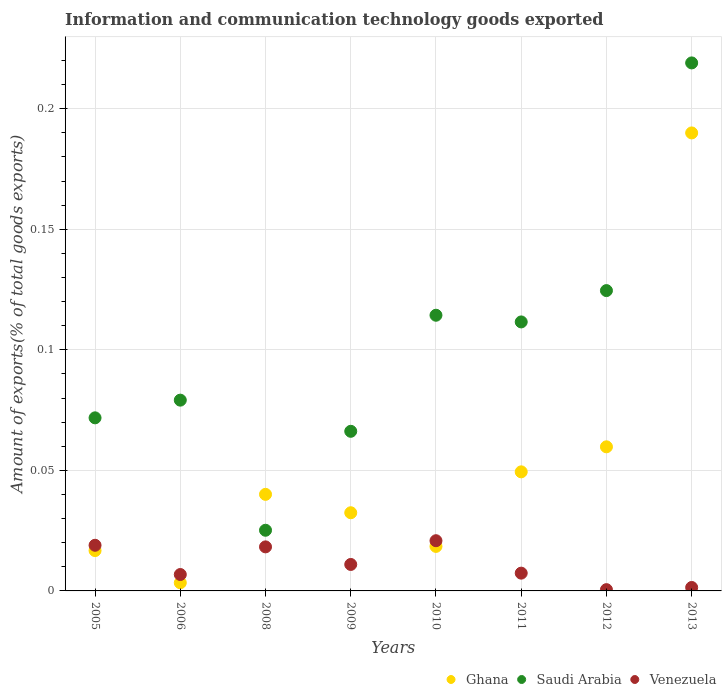Is the number of dotlines equal to the number of legend labels?
Offer a terse response. Yes. What is the amount of goods exported in Venezuela in 2013?
Your answer should be compact. 0. Across all years, what is the maximum amount of goods exported in Venezuela?
Provide a succinct answer. 0.02. Across all years, what is the minimum amount of goods exported in Ghana?
Offer a terse response. 0. In which year was the amount of goods exported in Venezuela maximum?
Your response must be concise. 2010. In which year was the amount of goods exported in Saudi Arabia minimum?
Provide a succinct answer. 2008. What is the total amount of goods exported in Venezuela in the graph?
Offer a very short reply. 0.09. What is the difference between the amount of goods exported in Ghana in 2009 and that in 2013?
Provide a succinct answer. -0.16. What is the difference between the amount of goods exported in Venezuela in 2011 and the amount of goods exported in Saudi Arabia in 2013?
Your answer should be compact. -0.21. What is the average amount of goods exported in Venezuela per year?
Your answer should be compact. 0.01. In the year 2008, what is the difference between the amount of goods exported in Ghana and amount of goods exported in Venezuela?
Provide a succinct answer. 0.02. In how many years, is the amount of goods exported in Venezuela greater than 0.19000000000000003 %?
Provide a succinct answer. 0. What is the ratio of the amount of goods exported in Ghana in 2008 to that in 2009?
Your answer should be very brief. 1.24. Is the amount of goods exported in Ghana in 2005 less than that in 2009?
Offer a terse response. Yes. Is the difference between the amount of goods exported in Ghana in 2005 and 2011 greater than the difference between the amount of goods exported in Venezuela in 2005 and 2011?
Keep it short and to the point. No. What is the difference between the highest and the second highest amount of goods exported in Venezuela?
Your response must be concise. 0. What is the difference between the highest and the lowest amount of goods exported in Saudi Arabia?
Your response must be concise. 0.19. Is the sum of the amount of goods exported in Saudi Arabia in 2005 and 2011 greater than the maximum amount of goods exported in Ghana across all years?
Give a very brief answer. No. Is it the case that in every year, the sum of the amount of goods exported in Venezuela and amount of goods exported in Saudi Arabia  is greater than the amount of goods exported in Ghana?
Your answer should be compact. Yes. Does the amount of goods exported in Ghana monotonically increase over the years?
Your response must be concise. No. Is the amount of goods exported in Ghana strictly greater than the amount of goods exported in Venezuela over the years?
Keep it short and to the point. No. Is the amount of goods exported in Saudi Arabia strictly less than the amount of goods exported in Ghana over the years?
Provide a short and direct response. No. How many dotlines are there?
Provide a succinct answer. 3. How many years are there in the graph?
Offer a very short reply. 8. What is the difference between two consecutive major ticks on the Y-axis?
Your answer should be compact. 0.05. Does the graph contain any zero values?
Your response must be concise. No. Does the graph contain grids?
Ensure brevity in your answer.  Yes. Where does the legend appear in the graph?
Keep it short and to the point. Bottom right. What is the title of the graph?
Offer a very short reply. Information and communication technology goods exported. Does "Micronesia" appear as one of the legend labels in the graph?
Offer a very short reply. No. What is the label or title of the Y-axis?
Your response must be concise. Amount of exports(% of total goods exports). What is the Amount of exports(% of total goods exports) in Ghana in 2005?
Provide a succinct answer. 0.02. What is the Amount of exports(% of total goods exports) in Saudi Arabia in 2005?
Your answer should be very brief. 0.07. What is the Amount of exports(% of total goods exports) of Venezuela in 2005?
Keep it short and to the point. 0.02. What is the Amount of exports(% of total goods exports) in Ghana in 2006?
Provide a succinct answer. 0. What is the Amount of exports(% of total goods exports) in Saudi Arabia in 2006?
Offer a terse response. 0.08. What is the Amount of exports(% of total goods exports) in Venezuela in 2006?
Offer a terse response. 0.01. What is the Amount of exports(% of total goods exports) in Ghana in 2008?
Make the answer very short. 0.04. What is the Amount of exports(% of total goods exports) of Saudi Arabia in 2008?
Your answer should be compact. 0.03. What is the Amount of exports(% of total goods exports) in Venezuela in 2008?
Offer a very short reply. 0.02. What is the Amount of exports(% of total goods exports) in Ghana in 2009?
Ensure brevity in your answer.  0.03. What is the Amount of exports(% of total goods exports) in Saudi Arabia in 2009?
Provide a succinct answer. 0.07. What is the Amount of exports(% of total goods exports) in Venezuela in 2009?
Your response must be concise. 0.01. What is the Amount of exports(% of total goods exports) of Ghana in 2010?
Your response must be concise. 0.02. What is the Amount of exports(% of total goods exports) of Saudi Arabia in 2010?
Ensure brevity in your answer.  0.11. What is the Amount of exports(% of total goods exports) of Venezuela in 2010?
Offer a very short reply. 0.02. What is the Amount of exports(% of total goods exports) in Ghana in 2011?
Give a very brief answer. 0.05. What is the Amount of exports(% of total goods exports) in Saudi Arabia in 2011?
Your answer should be compact. 0.11. What is the Amount of exports(% of total goods exports) of Venezuela in 2011?
Ensure brevity in your answer.  0.01. What is the Amount of exports(% of total goods exports) in Ghana in 2012?
Your response must be concise. 0.06. What is the Amount of exports(% of total goods exports) of Saudi Arabia in 2012?
Ensure brevity in your answer.  0.12. What is the Amount of exports(% of total goods exports) in Venezuela in 2012?
Keep it short and to the point. 0. What is the Amount of exports(% of total goods exports) of Ghana in 2013?
Your answer should be compact. 0.19. What is the Amount of exports(% of total goods exports) of Saudi Arabia in 2013?
Make the answer very short. 0.22. What is the Amount of exports(% of total goods exports) in Venezuela in 2013?
Offer a very short reply. 0. Across all years, what is the maximum Amount of exports(% of total goods exports) of Ghana?
Offer a terse response. 0.19. Across all years, what is the maximum Amount of exports(% of total goods exports) of Saudi Arabia?
Your response must be concise. 0.22. Across all years, what is the maximum Amount of exports(% of total goods exports) of Venezuela?
Your answer should be compact. 0.02. Across all years, what is the minimum Amount of exports(% of total goods exports) of Ghana?
Your answer should be compact. 0. Across all years, what is the minimum Amount of exports(% of total goods exports) of Saudi Arabia?
Your response must be concise. 0.03. Across all years, what is the minimum Amount of exports(% of total goods exports) of Venezuela?
Your answer should be compact. 0. What is the total Amount of exports(% of total goods exports) in Ghana in the graph?
Offer a terse response. 0.41. What is the total Amount of exports(% of total goods exports) of Saudi Arabia in the graph?
Provide a succinct answer. 0.81. What is the total Amount of exports(% of total goods exports) of Venezuela in the graph?
Offer a terse response. 0.09. What is the difference between the Amount of exports(% of total goods exports) of Ghana in 2005 and that in 2006?
Offer a terse response. 0.01. What is the difference between the Amount of exports(% of total goods exports) of Saudi Arabia in 2005 and that in 2006?
Give a very brief answer. -0.01. What is the difference between the Amount of exports(% of total goods exports) in Venezuela in 2005 and that in 2006?
Offer a terse response. 0.01. What is the difference between the Amount of exports(% of total goods exports) of Ghana in 2005 and that in 2008?
Provide a short and direct response. -0.02. What is the difference between the Amount of exports(% of total goods exports) of Saudi Arabia in 2005 and that in 2008?
Provide a short and direct response. 0.05. What is the difference between the Amount of exports(% of total goods exports) in Venezuela in 2005 and that in 2008?
Your answer should be very brief. 0. What is the difference between the Amount of exports(% of total goods exports) of Ghana in 2005 and that in 2009?
Offer a very short reply. -0.02. What is the difference between the Amount of exports(% of total goods exports) of Saudi Arabia in 2005 and that in 2009?
Keep it short and to the point. 0.01. What is the difference between the Amount of exports(% of total goods exports) of Venezuela in 2005 and that in 2009?
Keep it short and to the point. 0.01. What is the difference between the Amount of exports(% of total goods exports) of Ghana in 2005 and that in 2010?
Offer a very short reply. -0. What is the difference between the Amount of exports(% of total goods exports) of Saudi Arabia in 2005 and that in 2010?
Your answer should be compact. -0.04. What is the difference between the Amount of exports(% of total goods exports) of Venezuela in 2005 and that in 2010?
Offer a terse response. -0. What is the difference between the Amount of exports(% of total goods exports) of Ghana in 2005 and that in 2011?
Keep it short and to the point. -0.03. What is the difference between the Amount of exports(% of total goods exports) in Saudi Arabia in 2005 and that in 2011?
Provide a short and direct response. -0.04. What is the difference between the Amount of exports(% of total goods exports) in Venezuela in 2005 and that in 2011?
Your response must be concise. 0.01. What is the difference between the Amount of exports(% of total goods exports) in Ghana in 2005 and that in 2012?
Offer a very short reply. -0.04. What is the difference between the Amount of exports(% of total goods exports) in Saudi Arabia in 2005 and that in 2012?
Offer a terse response. -0.05. What is the difference between the Amount of exports(% of total goods exports) in Venezuela in 2005 and that in 2012?
Offer a very short reply. 0.02. What is the difference between the Amount of exports(% of total goods exports) in Ghana in 2005 and that in 2013?
Give a very brief answer. -0.17. What is the difference between the Amount of exports(% of total goods exports) of Saudi Arabia in 2005 and that in 2013?
Provide a short and direct response. -0.15. What is the difference between the Amount of exports(% of total goods exports) of Venezuela in 2005 and that in 2013?
Keep it short and to the point. 0.02. What is the difference between the Amount of exports(% of total goods exports) of Ghana in 2006 and that in 2008?
Your response must be concise. -0.04. What is the difference between the Amount of exports(% of total goods exports) of Saudi Arabia in 2006 and that in 2008?
Ensure brevity in your answer.  0.05. What is the difference between the Amount of exports(% of total goods exports) in Venezuela in 2006 and that in 2008?
Provide a succinct answer. -0.01. What is the difference between the Amount of exports(% of total goods exports) in Ghana in 2006 and that in 2009?
Provide a short and direct response. -0.03. What is the difference between the Amount of exports(% of total goods exports) in Saudi Arabia in 2006 and that in 2009?
Your response must be concise. 0.01. What is the difference between the Amount of exports(% of total goods exports) in Venezuela in 2006 and that in 2009?
Your response must be concise. -0. What is the difference between the Amount of exports(% of total goods exports) in Ghana in 2006 and that in 2010?
Offer a terse response. -0.02. What is the difference between the Amount of exports(% of total goods exports) of Saudi Arabia in 2006 and that in 2010?
Your answer should be compact. -0.04. What is the difference between the Amount of exports(% of total goods exports) of Venezuela in 2006 and that in 2010?
Ensure brevity in your answer.  -0.01. What is the difference between the Amount of exports(% of total goods exports) in Ghana in 2006 and that in 2011?
Give a very brief answer. -0.05. What is the difference between the Amount of exports(% of total goods exports) in Saudi Arabia in 2006 and that in 2011?
Your answer should be compact. -0.03. What is the difference between the Amount of exports(% of total goods exports) in Venezuela in 2006 and that in 2011?
Offer a very short reply. -0. What is the difference between the Amount of exports(% of total goods exports) in Ghana in 2006 and that in 2012?
Your response must be concise. -0.06. What is the difference between the Amount of exports(% of total goods exports) of Saudi Arabia in 2006 and that in 2012?
Provide a short and direct response. -0.05. What is the difference between the Amount of exports(% of total goods exports) of Venezuela in 2006 and that in 2012?
Offer a terse response. 0.01. What is the difference between the Amount of exports(% of total goods exports) in Ghana in 2006 and that in 2013?
Provide a succinct answer. -0.19. What is the difference between the Amount of exports(% of total goods exports) of Saudi Arabia in 2006 and that in 2013?
Your answer should be compact. -0.14. What is the difference between the Amount of exports(% of total goods exports) of Venezuela in 2006 and that in 2013?
Offer a terse response. 0.01. What is the difference between the Amount of exports(% of total goods exports) of Ghana in 2008 and that in 2009?
Ensure brevity in your answer.  0.01. What is the difference between the Amount of exports(% of total goods exports) of Saudi Arabia in 2008 and that in 2009?
Ensure brevity in your answer.  -0.04. What is the difference between the Amount of exports(% of total goods exports) in Venezuela in 2008 and that in 2009?
Offer a terse response. 0.01. What is the difference between the Amount of exports(% of total goods exports) of Ghana in 2008 and that in 2010?
Your response must be concise. 0.02. What is the difference between the Amount of exports(% of total goods exports) of Saudi Arabia in 2008 and that in 2010?
Provide a succinct answer. -0.09. What is the difference between the Amount of exports(% of total goods exports) of Venezuela in 2008 and that in 2010?
Provide a short and direct response. -0. What is the difference between the Amount of exports(% of total goods exports) in Ghana in 2008 and that in 2011?
Provide a succinct answer. -0.01. What is the difference between the Amount of exports(% of total goods exports) in Saudi Arabia in 2008 and that in 2011?
Your response must be concise. -0.09. What is the difference between the Amount of exports(% of total goods exports) of Venezuela in 2008 and that in 2011?
Make the answer very short. 0.01. What is the difference between the Amount of exports(% of total goods exports) of Ghana in 2008 and that in 2012?
Provide a succinct answer. -0.02. What is the difference between the Amount of exports(% of total goods exports) of Saudi Arabia in 2008 and that in 2012?
Give a very brief answer. -0.1. What is the difference between the Amount of exports(% of total goods exports) in Venezuela in 2008 and that in 2012?
Make the answer very short. 0.02. What is the difference between the Amount of exports(% of total goods exports) in Ghana in 2008 and that in 2013?
Keep it short and to the point. -0.15. What is the difference between the Amount of exports(% of total goods exports) of Saudi Arabia in 2008 and that in 2013?
Make the answer very short. -0.19. What is the difference between the Amount of exports(% of total goods exports) of Venezuela in 2008 and that in 2013?
Ensure brevity in your answer.  0.02. What is the difference between the Amount of exports(% of total goods exports) in Ghana in 2009 and that in 2010?
Provide a succinct answer. 0.01. What is the difference between the Amount of exports(% of total goods exports) in Saudi Arabia in 2009 and that in 2010?
Keep it short and to the point. -0.05. What is the difference between the Amount of exports(% of total goods exports) of Venezuela in 2009 and that in 2010?
Provide a short and direct response. -0.01. What is the difference between the Amount of exports(% of total goods exports) in Ghana in 2009 and that in 2011?
Ensure brevity in your answer.  -0.02. What is the difference between the Amount of exports(% of total goods exports) of Saudi Arabia in 2009 and that in 2011?
Provide a succinct answer. -0.05. What is the difference between the Amount of exports(% of total goods exports) of Venezuela in 2009 and that in 2011?
Your answer should be compact. 0. What is the difference between the Amount of exports(% of total goods exports) of Ghana in 2009 and that in 2012?
Your response must be concise. -0.03. What is the difference between the Amount of exports(% of total goods exports) in Saudi Arabia in 2009 and that in 2012?
Your answer should be very brief. -0.06. What is the difference between the Amount of exports(% of total goods exports) of Venezuela in 2009 and that in 2012?
Offer a terse response. 0.01. What is the difference between the Amount of exports(% of total goods exports) in Ghana in 2009 and that in 2013?
Your response must be concise. -0.16. What is the difference between the Amount of exports(% of total goods exports) of Saudi Arabia in 2009 and that in 2013?
Make the answer very short. -0.15. What is the difference between the Amount of exports(% of total goods exports) in Venezuela in 2009 and that in 2013?
Give a very brief answer. 0.01. What is the difference between the Amount of exports(% of total goods exports) of Ghana in 2010 and that in 2011?
Your response must be concise. -0.03. What is the difference between the Amount of exports(% of total goods exports) of Saudi Arabia in 2010 and that in 2011?
Give a very brief answer. 0. What is the difference between the Amount of exports(% of total goods exports) in Venezuela in 2010 and that in 2011?
Your answer should be very brief. 0.01. What is the difference between the Amount of exports(% of total goods exports) in Ghana in 2010 and that in 2012?
Give a very brief answer. -0.04. What is the difference between the Amount of exports(% of total goods exports) of Saudi Arabia in 2010 and that in 2012?
Your answer should be compact. -0.01. What is the difference between the Amount of exports(% of total goods exports) in Venezuela in 2010 and that in 2012?
Your answer should be compact. 0.02. What is the difference between the Amount of exports(% of total goods exports) in Ghana in 2010 and that in 2013?
Your response must be concise. -0.17. What is the difference between the Amount of exports(% of total goods exports) in Saudi Arabia in 2010 and that in 2013?
Keep it short and to the point. -0.1. What is the difference between the Amount of exports(% of total goods exports) in Venezuela in 2010 and that in 2013?
Give a very brief answer. 0.02. What is the difference between the Amount of exports(% of total goods exports) in Ghana in 2011 and that in 2012?
Provide a short and direct response. -0.01. What is the difference between the Amount of exports(% of total goods exports) of Saudi Arabia in 2011 and that in 2012?
Make the answer very short. -0.01. What is the difference between the Amount of exports(% of total goods exports) in Venezuela in 2011 and that in 2012?
Give a very brief answer. 0.01. What is the difference between the Amount of exports(% of total goods exports) of Ghana in 2011 and that in 2013?
Your answer should be very brief. -0.14. What is the difference between the Amount of exports(% of total goods exports) in Saudi Arabia in 2011 and that in 2013?
Provide a succinct answer. -0.11. What is the difference between the Amount of exports(% of total goods exports) of Venezuela in 2011 and that in 2013?
Provide a succinct answer. 0.01. What is the difference between the Amount of exports(% of total goods exports) of Ghana in 2012 and that in 2013?
Offer a terse response. -0.13. What is the difference between the Amount of exports(% of total goods exports) in Saudi Arabia in 2012 and that in 2013?
Provide a short and direct response. -0.09. What is the difference between the Amount of exports(% of total goods exports) in Venezuela in 2012 and that in 2013?
Give a very brief answer. -0. What is the difference between the Amount of exports(% of total goods exports) in Ghana in 2005 and the Amount of exports(% of total goods exports) in Saudi Arabia in 2006?
Provide a succinct answer. -0.06. What is the difference between the Amount of exports(% of total goods exports) of Ghana in 2005 and the Amount of exports(% of total goods exports) of Venezuela in 2006?
Offer a terse response. 0.01. What is the difference between the Amount of exports(% of total goods exports) of Saudi Arabia in 2005 and the Amount of exports(% of total goods exports) of Venezuela in 2006?
Ensure brevity in your answer.  0.07. What is the difference between the Amount of exports(% of total goods exports) of Ghana in 2005 and the Amount of exports(% of total goods exports) of Saudi Arabia in 2008?
Provide a succinct answer. -0.01. What is the difference between the Amount of exports(% of total goods exports) in Ghana in 2005 and the Amount of exports(% of total goods exports) in Venezuela in 2008?
Provide a short and direct response. -0. What is the difference between the Amount of exports(% of total goods exports) of Saudi Arabia in 2005 and the Amount of exports(% of total goods exports) of Venezuela in 2008?
Keep it short and to the point. 0.05. What is the difference between the Amount of exports(% of total goods exports) of Ghana in 2005 and the Amount of exports(% of total goods exports) of Saudi Arabia in 2009?
Provide a succinct answer. -0.05. What is the difference between the Amount of exports(% of total goods exports) in Ghana in 2005 and the Amount of exports(% of total goods exports) in Venezuela in 2009?
Your response must be concise. 0.01. What is the difference between the Amount of exports(% of total goods exports) in Saudi Arabia in 2005 and the Amount of exports(% of total goods exports) in Venezuela in 2009?
Offer a very short reply. 0.06. What is the difference between the Amount of exports(% of total goods exports) in Ghana in 2005 and the Amount of exports(% of total goods exports) in Saudi Arabia in 2010?
Make the answer very short. -0.1. What is the difference between the Amount of exports(% of total goods exports) in Ghana in 2005 and the Amount of exports(% of total goods exports) in Venezuela in 2010?
Your answer should be very brief. -0. What is the difference between the Amount of exports(% of total goods exports) in Saudi Arabia in 2005 and the Amount of exports(% of total goods exports) in Venezuela in 2010?
Provide a short and direct response. 0.05. What is the difference between the Amount of exports(% of total goods exports) of Ghana in 2005 and the Amount of exports(% of total goods exports) of Saudi Arabia in 2011?
Provide a succinct answer. -0.09. What is the difference between the Amount of exports(% of total goods exports) in Ghana in 2005 and the Amount of exports(% of total goods exports) in Venezuela in 2011?
Offer a terse response. 0.01. What is the difference between the Amount of exports(% of total goods exports) of Saudi Arabia in 2005 and the Amount of exports(% of total goods exports) of Venezuela in 2011?
Provide a succinct answer. 0.06. What is the difference between the Amount of exports(% of total goods exports) in Ghana in 2005 and the Amount of exports(% of total goods exports) in Saudi Arabia in 2012?
Offer a terse response. -0.11. What is the difference between the Amount of exports(% of total goods exports) in Ghana in 2005 and the Amount of exports(% of total goods exports) in Venezuela in 2012?
Provide a short and direct response. 0.02. What is the difference between the Amount of exports(% of total goods exports) of Saudi Arabia in 2005 and the Amount of exports(% of total goods exports) of Venezuela in 2012?
Offer a very short reply. 0.07. What is the difference between the Amount of exports(% of total goods exports) of Ghana in 2005 and the Amount of exports(% of total goods exports) of Saudi Arabia in 2013?
Offer a very short reply. -0.2. What is the difference between the Amount of exports(% of total goods exports) of Ghana in 2005 and the Amount of exports(% of total goods exports) of Venezuela in 2013?
Give a very brief answer. 0.02. What is the difference between the Amount of exports(% of total goods exports) of Saudi Arabia in 2005 and the Amount of exports(% of total goods exports) of Venezuela in 2013?
Your answer should be very brief. 0.07. What is the difference between the Amount of exports(% of total goods exports) in Ghana in 2006 and the Amount of exports(% of total goods exports) in Saudi Arabia in 2008?
Make the answer very short. -0.02. What is the difference between the Amount of exports(% of total goods exports) in Ghana in 2006 and the Amount of exports(% of total goods exports) in Venezuela in 2008?
Provide a short and direct response. -0.01. What is the difference between the Amount of exports(% of total goods exports) in Saudi Arabia in 2006 and the Amount of exports(% of total goods exports) in Venezuela in 2008?
Your answer should be compact. 0.06. What is the difference between the Amount of exports(% of total goods exports) in Ghana in 2006 and the Amount of exports(% of total goods exports) in Saudi Arabia in 2009?
Give a very brief answer. -0.06. What is the difference between the Amount of exports(% of total goods exports) in Ghana in 2006 and the Amount of exports(% of total goods exports) in Venezuela in 2009?
Offer a terse response. -0.01. What is the difference between the Amount of exports(% of total goods exports) in Saudi Arabia in 2006 and the Amount of exports(% of total goods exports) in Venezuela in 2009?
Keep it short and to the point. 0.07. What is the difference between the Amount of exports(% of total goods exports) in Ghana in 2006 and the Amount of exports(% of total goods exports) in Saudi Arabia in 2010?
Your response must be concise. -0.11. What is the difference between the Amount of exports(% of total goods exports) in Ghana in 2006 and the Amount of exports(% of total goods exports) in Venezuela in 2010?
Offer a terse response. -0.02. What is the difference between the Amount of exports(% of total goods exports) of Saudi Arabia in 2006 and the Amount of exports(% of total goods exports) of Venezuela in 2010?
Your answer should be very brief. 0.06. What is the difference between the Amount of exports(% of total goods exports) of Ghana in 2006 and the Amount of exports(% of total goods exports) of Saudi Arabia in 2011?
Give a very brief answer. -0.11. What is the difference between the Amount of exports(% of total goods exports) of Ghana in 2006 and the Amount of exports(% of total goods exports) of Venezuela in 2011?
Provide a succinct answer. -0. What is the difference between the Amount of exports(% of total goods exports) of Saudi Arabia in 2006 and the Amount of exports(% of total goods exports) of Venezuela in 2011?
Provide a succinct answer. 0.07. What is the difference between the Amount of exports(% of total goods exports) of Ghana in 2006 and the Amount of exports(% of total goods exports) of Saudi Arabia in 2012?
Offer a terse response. -0.12. What is the difference between the Amount of exports(% of total goods exports) of Ghana in 2006 and the Amount of exports(% of total goods exports) of Venezuela in 2012?
Your answer should be very brief. 0. What is the difference between the Amount of exports(% of total goods exports) of Saudi Arabia in 2006 and the Amount of exports(% of total goods exports) of Venezuela in 2012?
Your answer should be very brief. 0.08. What is the difference between the Amount of exports(% of total goods exports) of Ghana in 2006 and the Amount of exports(% of total goods exports) of Saudi Arabia in 2013?
Offer a very short reply. -0.22. What is the difference between the Amount of exports(% of total goods exports) in Ghana in 2006 and the Amount of exports(% of total goods exports) in Venezuela in 2013?
Offer a very short reply. 0. What is the difference between the Amount of exports(% of total goods exports) in Saudi Arabia in 2006 and the Amount of exports(% of total goods exports) in Venezuela in 2013?
Offer a terse response. 0.08. What is the difference between the Amount of exports(% of total goods exports) of Ghana in 2008 and the Amount of exports(% of total goods exports) of Saudi Arabia in 2009?
Offer a terse response. -0.03. What is the difference between the Amount of exports(% of total goods exports) in Ghana in 2008 and the Amount of exports(% of total goods exports) in Venezuela in 2009?
Your answer should be compact. 0.03. What is the difference between the Amount of exports(% of total goods exports) of Saudi Arabia in 2008 and the Amount of exports(% of total goods exports) of Venezuela in 2009?
Give a very brief answer. 0.01. What is the difference between the Amount of exports(% of total goods exports) of Ghana in 2008 and the Amount of exports(% of total goods exports) of Saudi Arabia in 2010?
Ensure brevity in your answer.  -0.07. What is the difference between the Amount of exports(% of total goods exports) in Ghana in 2008 and the Amount of exports(% of total goods exports) in Venezuela in 2010?
Provide a short and direct response. 0.02. What is the difference between the Amount of exports(% of total goods exports) of Saudi Arabia in 2008 and the Amount of exports(% of total goods exports) of Venezuela in 2010?
Provide a succinct answer. 0. What is the difference between the Amount of exports(% of total goods exports) of Ghana in 2008 and the Amount of exports(% of total goods exports) of Saudi Arabia in 2011?
Offer a very short reply. -0.07. What is the difference between the Amount of exports(% of total goods exports) of Ghana in 2008 and the Amount of exports(% of total goods exports) of Venezuela in 2011?
Make the answer very short. 0.03. What is the difference between the Amount of exports(% of total goods exports) of Saudi Arabia in 2008 and the Amount of exports(% of total goods exports) of Venezuela in 2011?
Provide a succinct answer. 0.02. What is the difference between the Amount of exports(% of total goods exports) of Ghana in 2008 and the Amount of exports(% of total goods exports) of Saudi Arabia in 2012?
Make the answer very short. -0.08. What is the difference between the Amount of exports(% of total goods exports) of Ghana in 2008 and the Amount of exports(% of total goods exports) of Venezuela in 2012?
Offer a terse response. 0.04. What is the difference between the Amount of exports(% of total goods exports) of Saudi Arabia in 2008 and the Amount of exports(% of total goods exports) of Venezuela in 2012?
Provide a succinct answer. 0.02. What is the difference between the Amount of exports(% of total goods exports) of Ghana in 2008 and the Amount of exports(% of total goods exports) of Saudi Arabia in 2013?
Keep it short and to the point. -0.18. What is the difference between the Amount of exports(% of total goods exports) in Ghana in 2008 and the Amount of exports(% of total goods exports) in Venezuela in 2013?
Provide a succinct answer. 0.04. What is the difference between the Amount of exports(% of total goods exports) in Saudi Arabia in 2008 and the Amount of exports(% of total goods exports) in Venezuela in 2013?
Keep it short and to the point. 0.02. What is the difference between the Amount of exports(% of total goods exports) in Ghana in 2009 and the Amount of exports(% of total goods exports) in Saudi Arabia in 2010?
Provide a succinct answer. -0.08. What is the difference between the Amount of exports(% of total goods exports) of Ghana in 2009 and the Amount of exports(% of total goods exports) of Venezuela in 2010?
Your answer should be very brief. 0.01. What is the difference between the Amount of exports(% of total goods exports) in Saudi Arabia in 2009 and the Amount of exports(% of total goods exports) in Venezuela in 2010?
Offer a terse response. 0.05. What is the difference between the Amount of exports(% of total goods exports) in Ghana in 2009 and the Amount of exports(% of total goods exports) in Saudi Arabia in 2011?
Make the answer very short. -0.08. What is the difference between the Amount of exports(% of total goods exports) in Ghana in 2009 and the Amount of exports(% of total goods exports) in Venezuela in 2011?
Your answer should be compact. 0.03. What is the difference between the Amount of exports(% of total goods exports) of Saudi Arabia in 2009 and the Amount of exports(% of total goods exports) of Venezuela in 2011?
Provide a succinct answer. 0.06. What is the difference between the Amount of exports(% of total goods exports) in Ghana in 2009 and the Amount of exports(% of total goods exports) in Saudi Arabia in 2012?
Offer a very short reply. -0.09. What is the difference between the Amount of exports(% of total goods exports) in Ghana in 2009 and the Amount of exports(% of total goods exports) in Venezuela in 2012?
Ensure brevity in your answer.  0.03. What is the difference between the Amount of exports(% of total goods exports) in Saudi Arabia in 2009 and the Amount of exports(% of total goods exports) in Venezuela in 2012?
Your response must be concise. 0.07. What is the difference between the Amount of exports(% of total goods exports) of Ghana in 2009 and the Amount of exports(% of total goods exports) of Saudi Arabia in 2013?
Provide a short and direct response. -0.19. What is the difference between the Amount of exports(% of total goods exports) in Ghana in 2009 and the Amount of exports(% of total goods exports) in Venezuela in 2013?
Your answer should be very brief. 0.03. What is the difference between the Amount of exports(% of total goods exports) of Saudi Arabia in 2009 and the Amount of exports(% of total goods exports) of Venezuela in 2013?
Offer a terse response. 0.06. What is the difference between the Amount of exports(% of total goods exports) in Ghana in 2010 and the Amount of exports(% of total goods exports) in Saudi Arabia in 2011?
Make the answer very short. -0.09. What is the difference between the Amount of exports(% of total goods exports) of Ghana in 2010 and the Amount of exports(% of total goods exports) of Venezuela in 2011?
Offer a very short reply. 0.01. What is the difference between the Amount of exports(% of total goods exports) of Saudi Arabia in 2010 and the Amount of exports(% of total goods exports) of Venezuela in 2011?
Your answer should be compact. 0.11. What is the difference between the Amount of exports(% of total goods exports) in Ghana in 2010 and the Amount of exports(% of total goods exports) in Saudi Arabia in 2012?
Keep it short and to the point. -0.11. What is the difference between the Amount of exports(% of total goods exports) in Ghana in 2010 and the Amount of exports(% of total goods exports) in Venezuela in 2012?
Offer a very short reply. 0.02. What is the difference between the Amount of exports(% of total goods exports) of Saudi Arabia in 2010 and the Amount of exports(% of total goods exports) of Venezuela in 2012?
Offer a very short reply. 0.11. What is the difference between the Amount of exports(% of total goods exports) of Ghana in 2010 and the Amount of exports(% of total goods exports) of Saudi Arabia in 2013?
Your response must be concise. -0.2. What is the difference between the Amount of exports(% of total goods exports) of Ghana in 2010 and the Amount of exports(% of total goods exports) of Venezuela in 2013?
Make the answer very short. 0.02. What is the difference between the Amount of exports(% of total goods exports) of Saudi Arabia in 2010 and the Amount of exports(% of total goods exports) of Venezuela in 2013?
Ensure brevity in your answer.  0.11. What is the difference between the Amount of exports(% of total goods exports) of Ghana in 2011 and the Amount of exports(% of total goods exports) of Saudi Arabia in 2012?
Provide a short and direct response. -0.08. What is the difference between the Amount of exports(% of total goods exports) of Ghana in 2011 and the Amount of exports(% of total goods exports) of Venezuela in 2012?
Offer a terse response. 0.05. What is the difference between the Amount of exports(% of total goods exports) of Saudi Arabia in 2011 and the Amount of exports(% of total goods exports) of Venezuela in 2012?
Your answer should be compact. 0.11. What is the difference between the Amount of exports(% of total goods exports) of Ghana in 2011 and the Amount of exports(% of total goods exports) of Saudi Arabia in 2013?
Your response must be concise. -0.17. What is the difference between the Amount of exports(% of total goods exports) of Ghana in 2011 and the Amount of exports(% of total goods exports) of Venezuela in 2013?
Make the answer very short. 0.05. What is the difference between the Amount of exports(% of total goods exports) in Saudi Arabia in 2011 and the Amount of exports(% of total goods exports) in Venezuela in 2013?
Provide a succinct answer. 0.11. What is the difference between the Amount of exports(% of total goods exports) in Ghana in 2012 and the Amount of exports(% of total goods exports) in Saudi Arabia in 2013?
Your answer should be compact. -0.16. What is the difference between the Amount of exports(% of total goods exports) in Ghana in 2012 and the Amount of exports(% of total goods exports) in Venezuela in 2013?
Offer a terse response. 0.06. What is the difference between the Amount of exports(% of total goods exports) in Saudi Arabia in 2012 and the Amount of exports(% of total goods exports) in Venezuela in 2013?
Your response must be concise. 0.12. What is the average Amount of exports(% of total goods exports) of Ghana per year?
Make the answer very short. 0.05. What is the average Amount of exports(% of total goods exports) of Saudi Arabia per year?
Your answer should be compact. 0.1. What is the average Amount of exports(% of total goods exports) of Venezuela per year?
Your response must be concise. 0.01. In the year 2005, what is the difference between the Amount of exports(% of total goods exports) of Ghana and Amount of exports(% of total goods exports) of Saudi Arabia?
Offer a terse response. -0.06. In the year 2005, what is the difference between the Amount of exports(% of total goods exports) in Ghana and Amount of exports(% of total goods exports) in Venezuela?
Your answer should be very brief. -0. In the year 2005, what is the difference between the Amount of exports(% of total goods exports) of Saudi Arabia and Amount of exports(% of total goods exports) of Venezuela?
Your answer should be compact. 0.05. In the year 2006, what is the difference between the Amount of exports(% of total goods exports) in Ghana and Amount of exports(% of total goods exports) in Saudi Arabia?
Offer a very short reply. -0.08. In the year 2006, what is the difference between the Amount of exports(% of total goods exports) in Ghana and Amount of exports(% of total goods exports) in Venezuela?
Give a very brief answer. -0. In the year 2006, what is the difference between the Amount of exports(% of total goods exports) in Saudi Arabia and Amount of exports(% of total goods exports) in Venezuela?
Provide a succinct answer. 0.07. In the year 2008, what is the difference between the Amount of exports(% of total goods exports) in Ghana and Amount of exports(% of total goods exports) in Saudi Arabia?
Provide a short and direct response. 0.01. In the year 2008, what is the difference between the Amount of exports(% of total goods exports) in Ghana and Amount of exports(% of total goods exports) in Venezuela?
Offer a terse response. 0.02. In the year 2008, what is the difference between the Amount of exports(% of total goods exports) of Saudi Arabia and Amount of exports(% of total goods exports) of Venezuela?
Make the answer very short. 0.01. In the year 2009, what is the difference between the Amount of exports(% of total goods exports) of Ghana and Amount of exports(% of total goods exports) of Saudi Arabia?
Provide a succinct answer. -0.03. In the year 2009, what is the difference between the Amount of exports(% of total goods exports) of Ghana and Amount of exports(% of total goods exports) of Venezuela?
Offer a very short reply. 0.02. In the year 2009, what is the difference between the Amount of exports(% of total goods exports) of Saudi Arabia and Amount of exports(% of total goods exports) of Venezuela?
Give a very brief answer. 0.06. In the year 2010, what is the difference between the Amount of exports(% of total goods exports) of Ghana and Amount of exports(% of total goods exports) of Saudi Arabia?
Your answer should be compact. -0.1. In the year 2010, what is the difference between the Amount of exports(% of total goods exports) in Ghana and Amount of exports(% of total goods exports) in Venezuela?
Your answer should be very brief. -0. In the year 2010, what is the difference between the Amount of exports(% of total goods exports) of Saudi Arabia and Amount of exports(% of total goods exports) of Venezuela?
Offer a very short reply. 0.09. In the year 2011, what is the difference between the Amount of exports(% of total goods exports) in Ghana and Amount of exports(% of total goods exports) in Saudi Arabia?
Make the answer very short. -0.06. In the year 2011, what is the difference between the Amount of exports(% of total goods exports) of Ghana and Amount of exports(% of total goods exports) of Venezuela?
Provide a short and direct response. 0.04. In the year 2011, what is the difference between the Amount of exports(% of total goods exports) of Saudi Arabia and Amount of exports(% of total goods exports) of Venezuela?
Your answer should be very brief. 0.1. In the year 2012, what is the difference between the Amount of exports(% of total goods exports) of Ghana and Amount of exports(% of total goods exports) of Saudi Arabia?
Offer a terse response. -0.06. In the year 2012, what is the difference between the Amount of exports(% of total goods exports) of Ghana and Amount of exports(% of total goods exports) of Venezuela?
Provide a short and direct response. 0.06. In the year 2012, what is the difference between the Amount of exports(% of total goods exports) of Saudi Arabia and Amount of exports(% of total goods exports) of Venezuela?
Your answer should be compact. 0.12. In the year 2013, what is the difference between the Amount of exports(% of total goods exports) of Ghana and Amount of exports(% of total goods exports) of Saudi Arabia?
Provide a short and direct response. -0.03. In the year 2013, what is the difference between the Amount of exports(% of total goods exports) in Ghana and Amount of exports(% of total goods exports) in Venezuela?
Offer a terse response. 0.19. In the year 2013, what is the difference between the Amount of exports(% of total goods exports) of Saudi Arabia and Amount of exports(% of total goods exports) of Venezuela?
Ensure brevity in your answer.  0.22. What is the ratio of the Amount of exports(% of total goods exports) of Ghana in 2005 to that in 2006?
Provide a succinct answer. 4.95. What is the ratio of the Amount of exports(% of total goods exports) in Saudi Arabia in 2005 to that in 2006?
Give a very brief answer. 0.91. What is the ratio of the Amount of exports(% of total goods exports) in Venezuela in 2005 to that in 2006?
Your answer should be very brief. 2.78. What is the ratio of the Amount of exports(% of total goods exports) in Ghana in 2005 to that in 2008?
Ensure brevity in your answer.  0.42. What is the ratio of the Amount of exports(% of total goods exports) in Saudi Arabia in 2005 to that in 2008?
Your answer should be very brief. 2.85. What is the ratio of the Amount of exports(% of total goods exports) of Venezuela in 2005 to that in 2008?
Keep it short and to the point. 1.04. What is the ratio of the Amount of exports(% of total goods exports) of Ghana in 2005 to that in 2009?
Ensure brevity in your answer.  0.52. What is the ratio of the Amount of exports(% of total goods exports) of Saudi Arabia in 2005 to that in 2009?
Ensure brevity in your answer.  1.08. What is the ratio of the Amount of exports(% of total goods exports) of Venezuela in 2005 to that in 2009?
Provide a short and direct response. 1.72. What is the ratio of the Amount of exports(% of total goods exports) in Ghana in 2005 to that in 2010?
Provide a short and direct response. 0.91. What is the ratio of the Amount of exports(% of total goods exports) of Saudi Arabia in 2005 to that in 2010?
Give a very brief answer. 0.63. What is the ratio of the Amount of exports(% of total goods exports) in Venezuela in 2005 to that in 2010?
Your answer should be very brief. 0.91. What is the ratio of the Amount of exports(% of total goods exports) of Ghana in 2005 to that in 2011?
Your answer should be compact. 0.34. What is the ratio of the Amount of exports(% of total goods exports) of Saudi Arabia in 2005 to that in 2011?
Keep it short and to the point. 0.64. What is the ratio of the Amount of exports(% of total goods exports) in Venezuela in 2005 to that in 2011?
Keep it short and to the point. 2.57. What is the ratio of the Amount of exports(% of total goods exports) of Ghana in 2005 to that in 2012?
Make the answer very short. 0.28. What is the ratio of the Amount of exports(% of total goods exports) of Saudi Arabia in 2005 to that in 2012?
Keep it short and to the point. 0.58. What is the ratio of the Amount of exports(% of total goods exports) of Venezuela in 2005 to that in 2012?
Your answer should be compact. 35.78. What is the ratio of the Amount of exports(% of total goods exports) in Ghana in 2005 to that in 2013?
Your answer should be very brief. 0.09. What is the ratio of the Amount of exports(% of total goods exports) in Saudi Arabia in 2005 to that in 2013?
Offer a terse response. 0.33. What is the ratio of the Amount of exports(% of total goods exports) in Venezuela in 2005 to that in 2013?
Make the answer very short. 13.26. What is the ratio of the Amount of exports(% of total goods exports) of Ghana in 2006 to that in 2008?
Offer a terse response. 0.08. What is the ratio of the Amount of exports(% of total goods exports) of Saudi Arabia in 2006 to that in 2008?
Your answer should be compact. 3.14. What is the ratio of the Amount of exports(% of total goods exports) of Venezuela in 2006 to that in 2008?
Keep it short and to the point. 0.37. What is the ratio of the Amount of exports(% of total goods exports) of Ghana in 2006 to that in 2009?
Provide a succinct answer. 0.1. What is the ratio of the Amount of exports(% of total goods exports) of Saudi Arabia in 2006 to that in 2009?
Make the answer very short. 1.2. What is the ratio of the Amount of exports(% of total goods exports) in Venezuela in 2006 to that in 2009?
Your response must be concise. 0.62. What is the ratio of the Amount of exports(% of total goods exports) of Ghana in 2006 to that in 2010?
Keep it short and to the point. 0.18. What is the ratio of the Amount of exports(% of total goods exports) in Saudi Arabia in 2006 to that in 2010?
Provide a short and direct response. 0.69. What is the ratio of the Amount of exports(% of total goods exports) in Venezuela in 2006 to that in 2010?
Make the answer very short. 0.33. What is the ratio of the Amount of exports(% of total goods exports) in Ghana in 2006 to that in 2011?
Provide a succinct answer. 0.07. What is the ratio of the Amount of exports(% of total goods exports) of Saudi Arabia in 2006 to that in 2011?
Your response must be concise. 0.71. What is the ratio of the Amount of exports(% of total goods exports) in Venezuela in 2006 to that in 2011?
Your answer should be compact. 0.92. What is the ratio of the Amount of exports(% of total goods exports) of Ghana in 2006 to that in 2012?
Your response must be concise. 0.06. What is the ratio of the Amount of exports(% of total goods exports) in Saudi Arabia in 2006 to that in 2012?
Your answer should be compact. 0.64. What is the ratio of the Amount of exports(% of total goods exports) in Venezuela in 2006 to that in 2012?
Offer a terse response. 12.86. What is the ratio of the Amount of exports(% of total goods exports) in Ghana in 2006 to that in 2013?
Ensure brevity in your answer.  0.02. What is the ratio of the Amount of exports(% of total goods exports) in Saudi Arabia in 2006 to that in 2013?
Provide a short and direct response. 0.36. What is the ratio of the Amount of exports(% of total goods exports) in Venezuela in 2006 to that in 2013?
Offer a terse response. 4.76. What is the ratio of the Amount of exports(% of total goods exports) in Ghana in 2008 to that in 2009?
Keep it short and to the point. 1.24. What is the ratio of the Amount of exports(% of total goods exports) of Saudi Arabia in 2008 to that in 2009?
Keep it short and to the point. 0.38. What is the ratio of the Amount of exports(% of total goods exports) in Venezuela in 2008 to that in 2009?
Offer a terse response. 1.66. What is the ratio of the Amount of exports(% of total goods exports) in Ghana in 2008 to that in 2010?
Make the answer very short. 2.17. What is the ratio of the Amount of exports(% of total goods exports) of Saudi Arabia in 2008 to that in 2010?
Give a very brief answer. 0.22. What is the ratio of the Amount of exports(% of total goods exports) of Venezuela in 2008 to that in 2010?
Ensure brevity in your answer.  0.88. What is the ratio of the Amount of exports(% of total goods exports) of Ghana in 2008 to that in 2011?
Offer a terse response. 0.81. What is the ratio of the Amount of exports(% of total goods exports) in Saudi Arabia in 2008 to that in 2011?
Your answer should be very brief. 0.23. What is the ratio of the Amount of exports(% of total goods exports) in Venezuela in 2008 to that in 2011?
Ensure brevity in your answer.  2.48. What is the ratio of the Amount of exports(% of total goods exports) of Ghana in 2008 to that in 2012?
Offer a terse response. 0.67. What is the ratio of the Amount of exports(% of total goods exports) of Saudi Arabia in 2008 to that in 2012?
Your response must be concise. 0.2. What is the ratio of the Amount of exports(% of total goods exports) in Venezuela in 2008 to that in 2012?
Make the answer very short. 34.52. What is the ratio of the Amount of exports(% of total goods exports) in Ghana in 2008 to that in 2013?
Make the answer very short. 0.21. What is the ratio of the Amount of exports(% of total goods exports) of Saudi Arabia in 2008 to that in 2013?
Your response must be concise. 0.11. What is the ratio of the Amount of exports(% of total goods exports) in Venezuela in 2008 to that in 2013?
Give a very brief answer. 12.79. What is the ratio of the Amount of exports(% of total goods exports) of Ghana in 2009 to that in 2010?
Offer a very short reply. 1.76. What is the ratio of the Amount of exports(% of total goods exports) in Saudi Arabia in 2009 to that in 2010?
Offer a very short reply. 0.58. What is the ratio of the Amount of exports(% of total goods exports) of Venezuela in 2009 to that in 2010?
Give a very brief answer. 0.53. What is the ratio of the Amount of exports(% of total goods exports) in Ghana in 2009 to that in 2011?
Provide a short and direct response. 0.66. What is the ratio of the Amount of exports(% of total goods exports) of Saudi Arabia in 2009 to that in 2011?
Your answer should be compact. 0.59. What is the ratio of the Amount of exports(% of total goods exports) of Venezuela in 2009 to that in 2011?
Provide a short and direct response. 1.49. What is the ratio of the Amount of exports(% of total goods exports) of Ghana in 2009 to that in 2012?
Offer a terse response. 0.54. What is the ratio of the Amount of exports(% of total goods exports) of Saudi Arabia in 2009 to that in 2012?
Offer a terse response. 0.53. What is the ratio of the Amount of exports(% of total goods exports) in Venezuela in 2009 to that in 2012?
Provide a succinct answer. 20.74. What is the ratio of the Amount of exports(% of total goods exports) in Ghana in 2009 to that in 2013?
Make the answer very short. 0.17. What is the ratio of the Amount of exports(% of total goods exports) in Saudi Arabia in 2009 to that in 2013?
Offer a terse response. 0.3. What is the ratio of the Amount of exports(% of total goods exports) in Venezuela in 2009 to that in 2013?
Ensure brevity in your answer.  7.69. What is the ratio of the Amount of exports(% of total goods exports) in Ghana in 2010 to that in 2011?
Your response must be concise. 0.37. What is the ratio of the Amount of exports(% of total goods exports) of Saudi Arabia in 2010 to that in 2011?
Your response must be concise. 1.02. What is the ratio of the Amount of exports(% of total goods exports) of Venezuela in 2010 to that in 2011?
Ensure brevity in your answer.  2.82. What is the ratio of the Amount of exports(% of total goods exports) of Ghana in 2010 to that in 2012?
Your answer should be very brief. 0.31. What is the ratio of the Amount of exports(% of total goods exports) in Saudi Arabia in 2010 to that in 2012?
Your answer should be very brief. 0.92. What is the ratio of the Amount of exports(% of total goods exports) of Venezuela in 2010 to that in 2012?
Make the answer very short. 39.35. What is the ratio of the Amount of exports(% of total goods exports) in Ghana in 2010 to that in 2013?
Your answer should be compact. 0.1. What is the ratio of the Amount of exports(% of total goods exports) in Saudi Arabia in 2010 to that in 2013?
Your answer should be very brief. 0.52. What is the ratio of the Amount of exports(% of total goods exports) in Venezuela in 2010 to that in 2013?
Make the answer very short. 14.58. What is the ratio of the Amount of exports(% of total goods exports) of Ghana in 2011 to that in 2012?
Your response must be concise. 0.83. What is the ratio of the Amount of exports(% of total goods exports) of Saudi Arabia in 2011 to that in 2012?
Give a very brief answer. 0.9. What is the ratio of the Amount of exports(% of total goods exports) of Venezuela in 2011 to that in 2012?
Make the answer very short. 13.93. What is the ratio of the Amount of exports(% of total goods exports) in Ghana in 2011 to that in 2013?
Ensure brevity in your answer.  0.26. What is the ratio of the Amount of exports(% of total goods exports) in Saudi Arabia in 2011 to that in 2013?
Make the answer very short. 0.51. What is the ratio of the Amount of exports(% of total goods exports) of Venezuela in 2011 to that in 2013?
Give a very brief answer. 5.16. What is the ratio of the Amount of exports(% of total goods exports) of Ghana in 2012 to that in 2013?
Provide a short and direct response. 0.31. What is the ratio of the Amount of exports(% of total goods exports) in Saudi Arabia in 2012 to that in 2013?
Ensure brevity in your answer.  0.57. What is the ratio of the Amount of exports(% of total goods exports) in Venezuela in 2012 to that in 2013?
Make the answer very short. 0.37. What is the difference between the highest and the second highest Amount of exports(% of total goods exports) of Ghana?
Keep it short and to the point. 0.13. What is the difference between the highest and the second highest Amount of exports(% of total goods exports) in Saudi Arabia?
Offer a terse response. 0.09. What is the difference between the highest and the second highest Amount of exports(% of total goods exports) of Venezuela?
Give a very brief answer. 0. What is the difference between the highest and the lowest Amount of exports(% of total goods exports) of Ghana?
Your answer should be very brief. 0.19. What is the difference between the highest and the lowest Amount of exports(% of total goods exports) in Saudi Arabia?
Give a very brief answer. 0.19. What is the difference between the highest and the lowest Amount of exports(% of total goods exports) in Venezuela?
Ensure brevity in your answer.  0.02. 